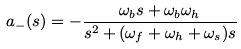<formula> <loc_0><loc_0><loc_500><loc_500>a _ { - } ( s ) = - \frac { \omega _ { b } s + \omega _ { b } \omega _ { h } } { s ^ { 2 } + ( \omega _ { f } + \omega _ { h } + \omega _ { s } ) s }</formula> 